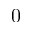Convert formula to latex. <formula><loc_0><loc_0><loc_500><loc_500>0</formula> 